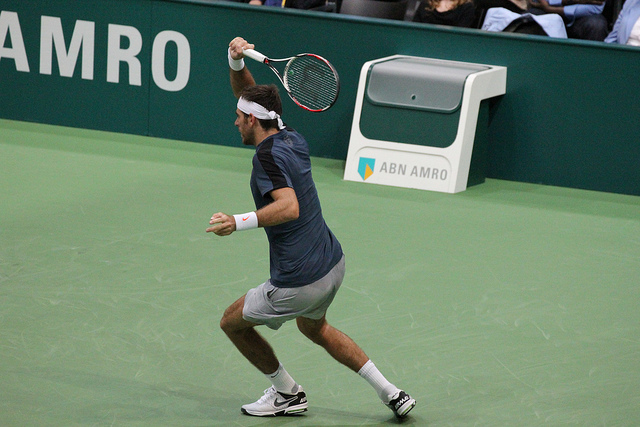Can you describe what's happening in the photo? The photo captures a tennis player mid-action during a match. The athlete appears to be right-handed and is possibly preparing to hit a backhand shot. The setting is an indoor tennis court, and importantly, ABN AMRO's sponsorship is evident from the prominent branding beside the court. What can you tell me about the equipment the player is using? The player is using a modern, graphite composite tennis racket, which is standard for contemporary professional play. The racket has a mid-plus head size suited for control and power balance. The player is also dressed in professional-grade tennis apparel and shoes, which provide support and flexibility for the intense movement required in the sport. 